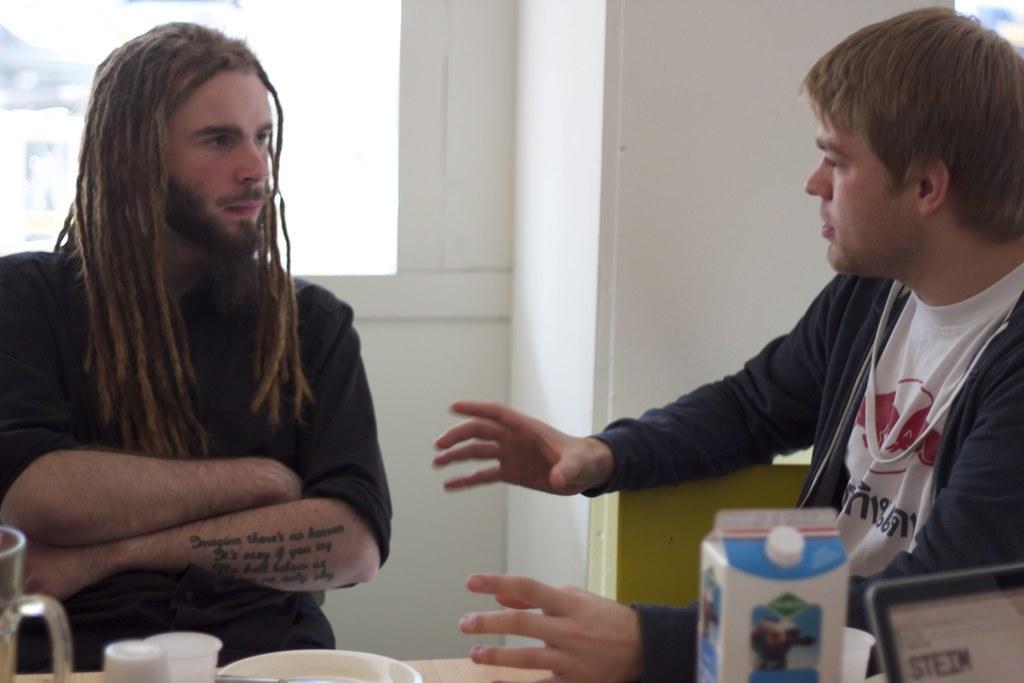Could you give a brief overview of what you see in this image? In this image there are two persons sitting on the chairs, there are glasses, plate, a sachet, a device on the table, and in the background there is wall, window. 